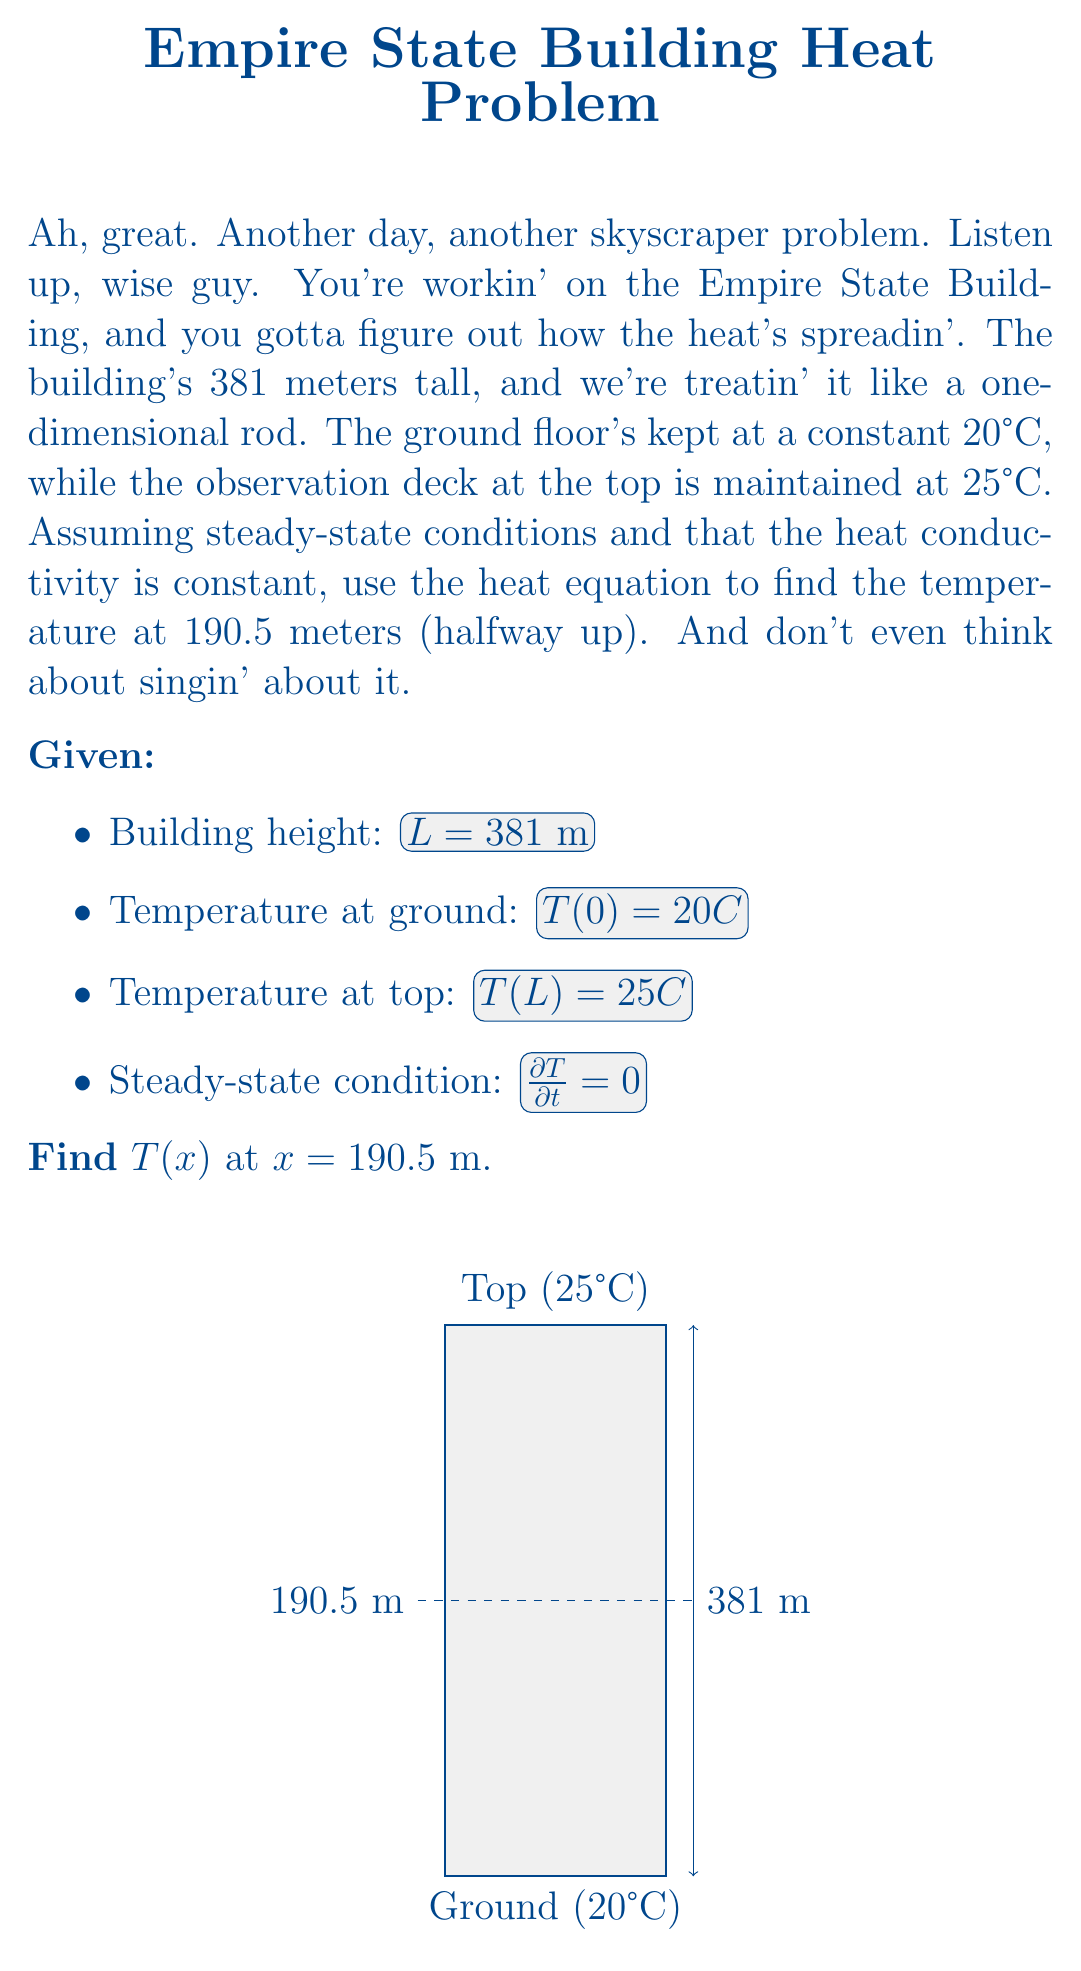Show me your answer to this math problem. Alright, let's break this down without any Broadway nonsense:

1) In steady-state, the heat equation reduces to:

   $$\frac{d^2T}{dx^2} = 0$$

2) Integrate this twice:

   $$\frac{dT}{dx} = C_1$$
   $$T(x) = C_1x + C_2$$

3) Now, use the boundary conditions to find $C_1$ and $C_2$:

   At $x = 0$: $T(0) = C_2 = 20$
   At $x = L$: $T(L) = C_1L + 20 = 25$

4) Solve for $C_1$:

   $$C_1 = \frac{25 - 20}{381} = \frac{5}{381}$$

5) So, the temperature distribution is:

   $$T(x) = \frac{5}{381}x + 20$$

6) At $x = 190.5$ m (halfway up):

   $$T(190.5) = \frac{5}{381}(190.5) + 20 = 2.5 + 20 = 22.5°C$$

There ya have it. No jazz hands required.
Answer: 22.5°C 